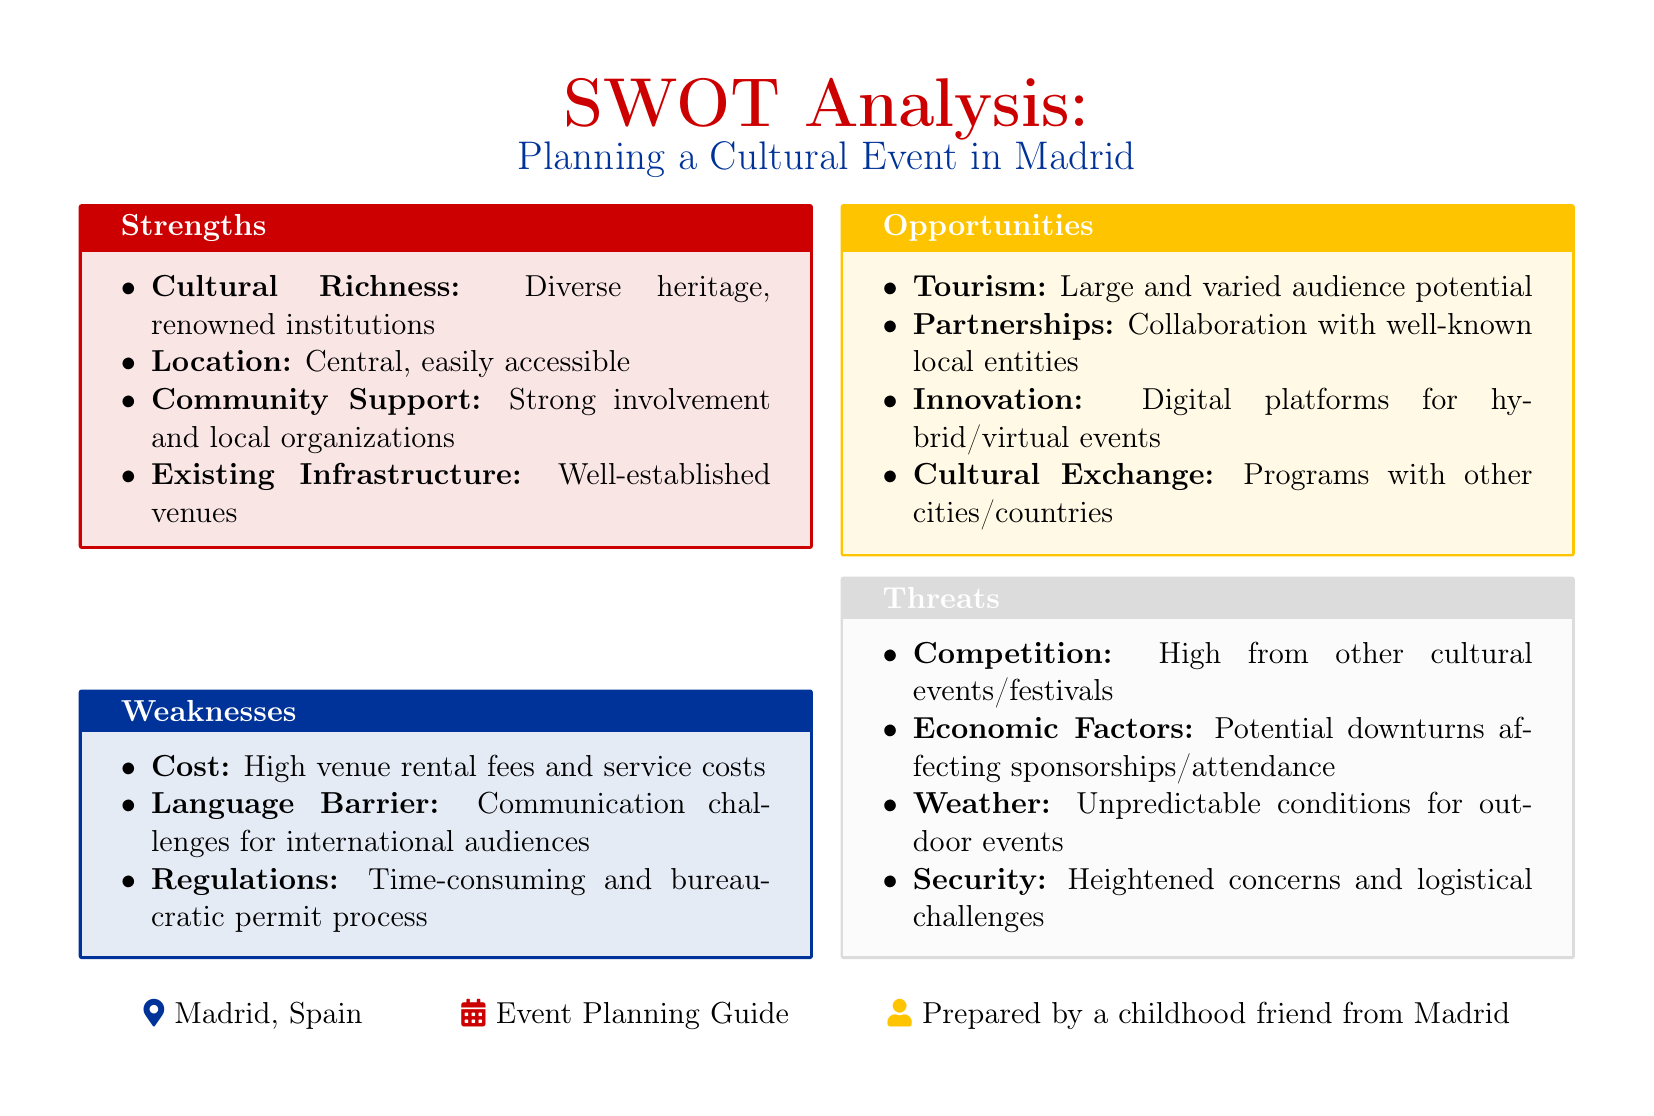What are the strengths of planning a cultural event in Madrid? The strengths listed include cultural richness, location, community support, and existing infrastructure.
Answer: Cultural Richness, Location, Community Support, Existing Infrastructure What is a weakness related to communication for cultural events? The document mentions communication challenges due to language differences for international audiences.
Answer: Language Barrier What is one of the opportunities mentioned for cultural events? The document lists tourism as a potential opportunity, indicating a large audience base.
Answer: Tourism How many threats are identified in the SWOT analysis? The document enumerates four threats pertaining to competition, economic factors, weather, and security.
Answer: Four Which strength highlights community participation? The strength that emphasizes local involvement in events refers to community support.
Answer: Community Support What is the color associated with weaknesses in the document? The color that designates weaknesses is specified as Madrid blue.
Answer: Madrid Blue What collaboration opportunity is suggested in the analysis? The SWOT analysis suggests collaboration with well-known local entities as a partnership opportunity.
Answer: Partnerships What factor could negatively impact sponsorships for cultural events? Economic downturns are mentioned as a threat that could affect sponsorships and attendance.
Answer: Economic Factors 